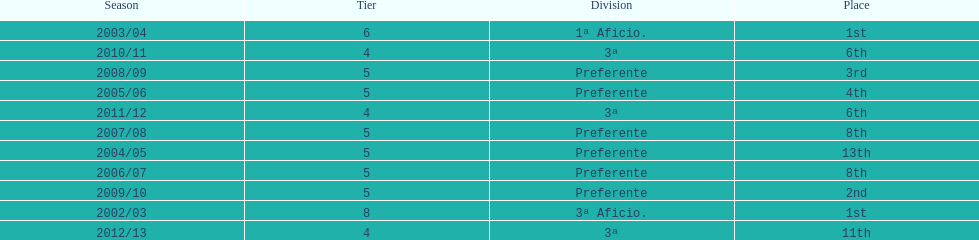How many seasons did internacional de madrid cf play in the preferente division? 6. 